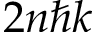<formula> <loc_0><loc_0><loc_500><loc_500>2 n \hbar { k }</formula> 